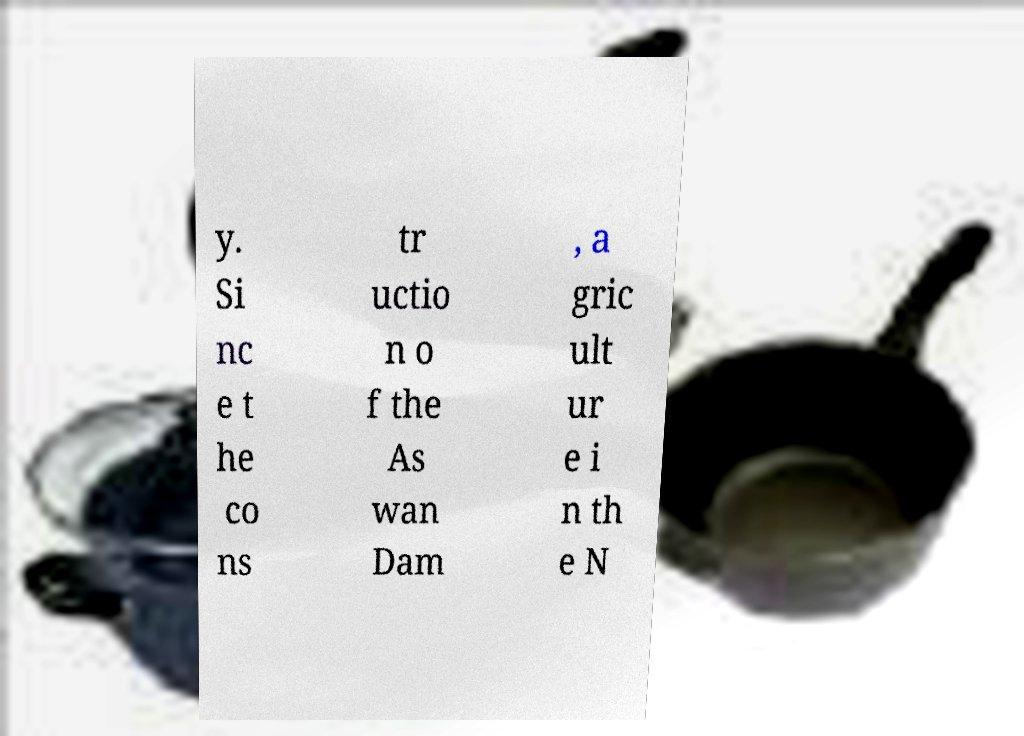For documentation purposes, I need the text within this image transcribed. Could you provide that? y. Si nc e t he co ns tr uctio n o f the As wan Dam , a gric ult ur e i n th e N 